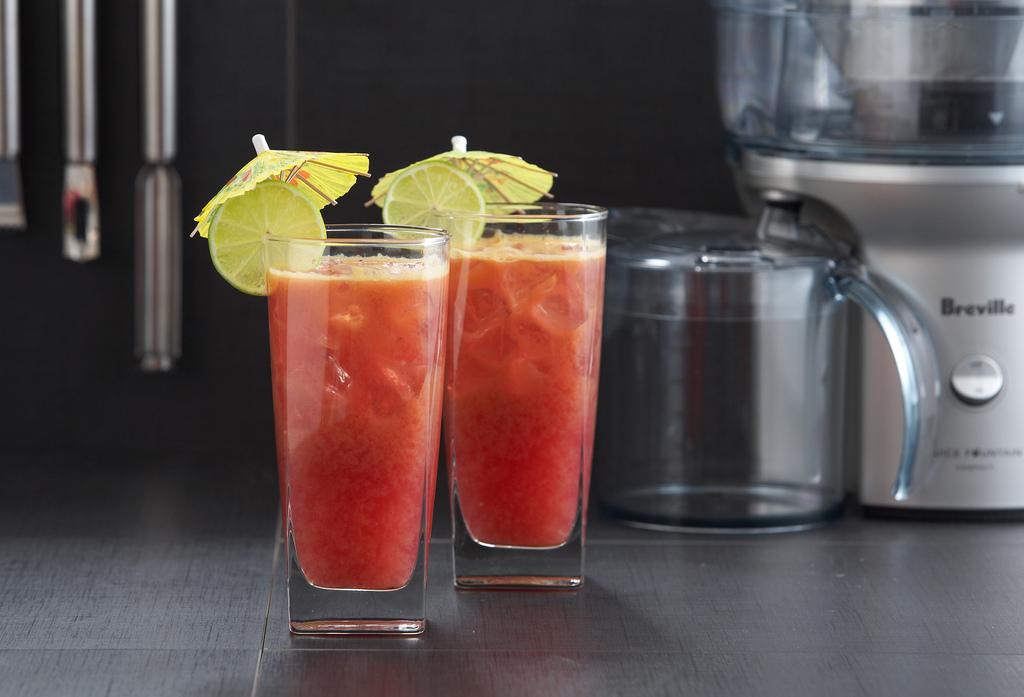What brand of machine in the back right?
Give a very brief answer. Breville. What is the brand of the mixer?
Provide a short and direct response. Breville. 